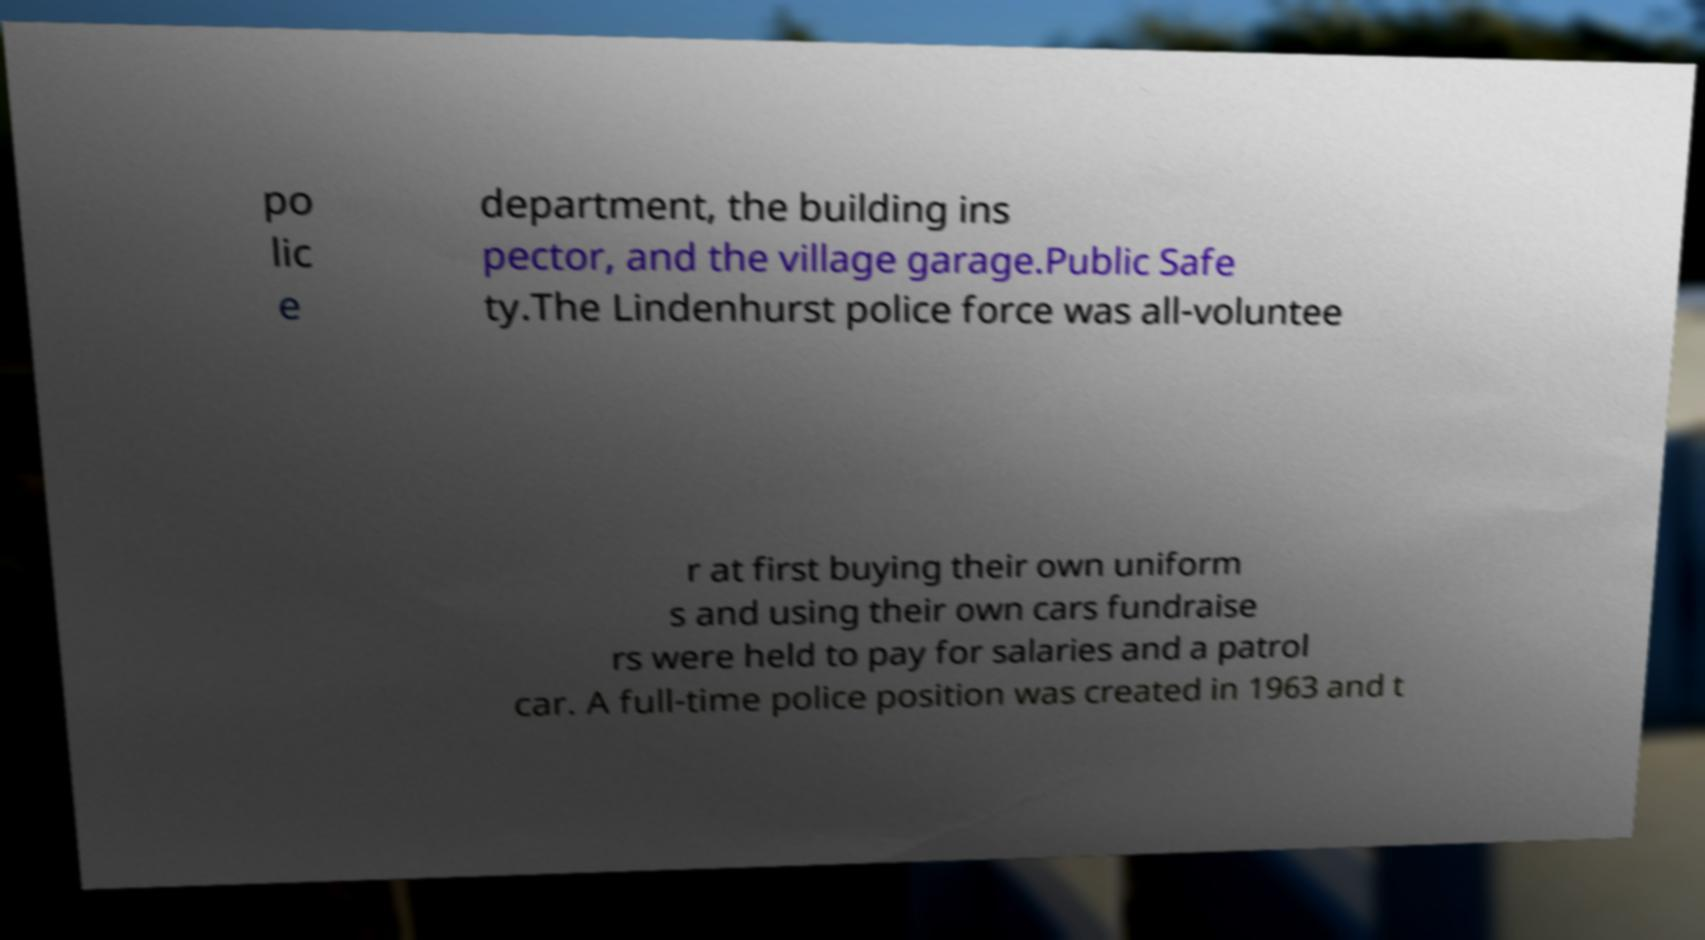Could you assist in decoding the text presented in this image and type it out clearly? po lic e department, the building ins pector, and the village garage.Public Safe ty.The Lindenhurst police force was all-voluntee r at first buying their own uniform s and using their own cars fundraise rs were held to pay for salaries and a patrol car. A full-time police position was created in 1963 and t 